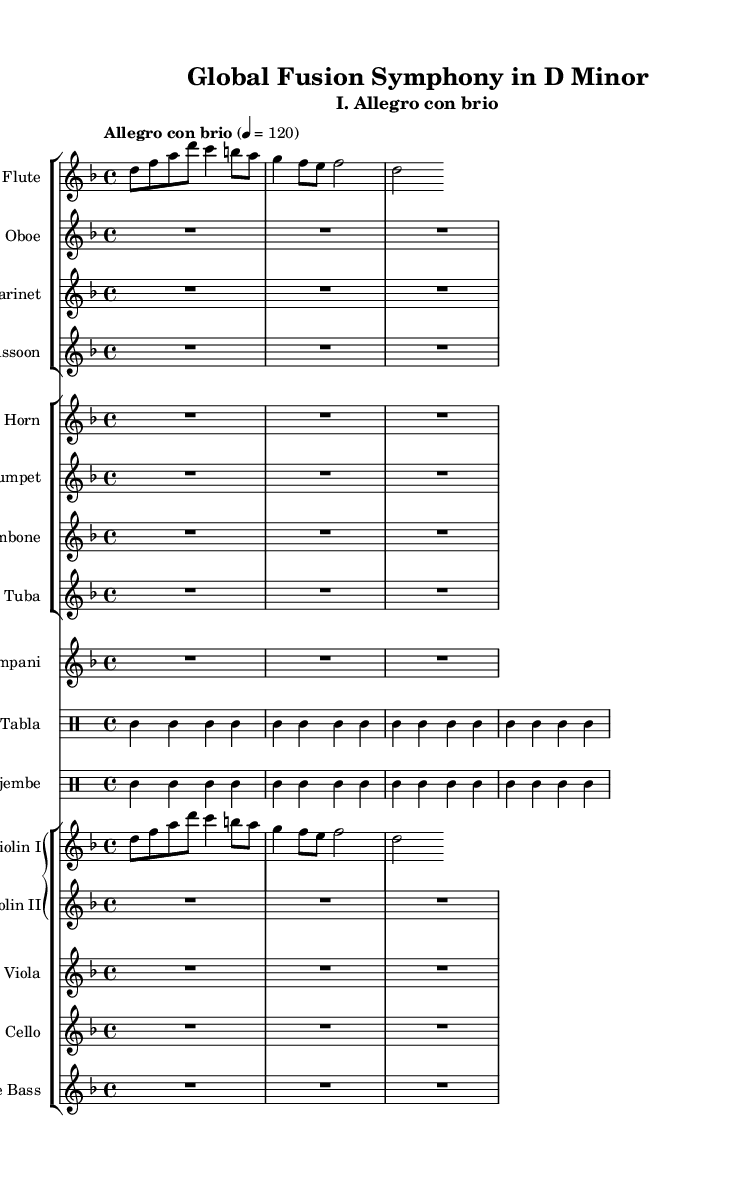What is the key signature of this symphony? The key signature is D minor, which has one flat (B flat). This is determined by checking the key signature indicated at the beginning of the score.
Answer: D minor What is the time signature of this symphony? The time signature is 4/4, which indicates four beats per measure. This is shown at the beginning of the score.
Answer: 4/4 What is the tempo marking for this symphony? The tempo marking is "Allegro con brio," which indicates a lively and spirited pace. This is found at the start of the score.
Answer: Allegro con brio How many types of percussion instruments are used in this symphony? There are two types of percussion instruments: tabla and djembe, as they are the only listed percussion instruments in the music score.
Answer: 2 Which woodwind instrument is noted to have rests throughout the first section? The oboe has rests, noted by the "R1*3" indicating three measures of rest. This shows there are no notes played during those measures.
Answer: Oboe How do the strings harmonically interact with the wind instruments in this symphony? The string instruments, including violins, viola, cello, and bass, perform melodic lines and often harmonize with wind instruments like flute and clarinet, which creates a rich textural interaction and underscores thematic ideas. However, specific interactions are depicted in their respective staves and require analyzing the written notes, indicating how they complement each other harmonically.
Answer: They harmonically interact What unique elements of world music are incorporated into this symphony? The symphony incorporates elements from world music through the use of traditional percussion instruments, specifically the tabla and djembe, which are rooted in different cultural musical traditions. This is indicated by their presence on the score, distinguishing them from traditional Western orchestral percussion.
Answer: Tabla and djembe 